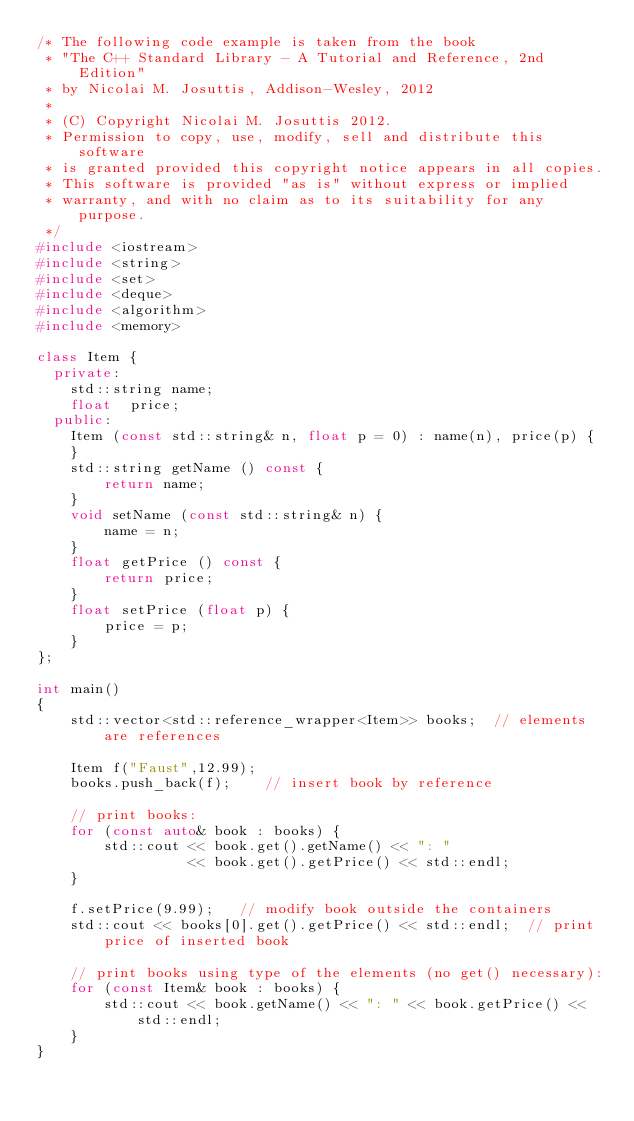Convert code to text. <code><loc_0><loc_0><loc_500><loc_500><_C++_>/* The following code example is taken from the book
 * "The C++ Standard Library - A Tutorial and Reference, 2nd Edition"
 * by Nicolai M. Josuttis, Addison-Wesley, 2012
 *
 * (C) Copyright Nicolai M. Josuttis 2012.
 * Permission to copy, use, modify, sell and distribute this software
 * is granted provided this copyright notice appears in all copies.
 * This software is provided "as is" without express or implied
 * warranty, and with no claim as to its suitability for any purpose.
 */
#include <iostream>
#include <string>
#include <set>
#include <deque>
#include <algorithm>
#include <memory>

class Item {
  private:
    std::string name;
    float  price;
  public:
    Item (const std::string& n, float p = 0) : name(n), price(p) {
    }
    std::string getName () const {
        return name;
    }
    void setName (const std::string& n) {
        name = n;
    }
    float getPrice () const {
        return price;
    }
    float setPrice (float p) {
        price = p;
    }
};

int main()
{
    std::vector<std::reference_wrapper<Item>> books;  // elements are references

    Item f("Faust",12.99);
    books.push_back(f);    // insert book by reference

    // print books:
    for (const auto& book : books) {
        std::cout << book.get().getName() << ": "
                  << book.get().getPrice() << std::endl;
    }

    f.setPrice(9.99);   // modify book outside the containers
    std::cout << books[0].get().getPrice() << std::endl;  // print price of inserted book

    // print books using type of the elements (no get() necessary):
    for (const Item& book : books) {
        std::cout << book.getName() << ": " << book.getPrice() << std::endl;
    }
}
</code> 